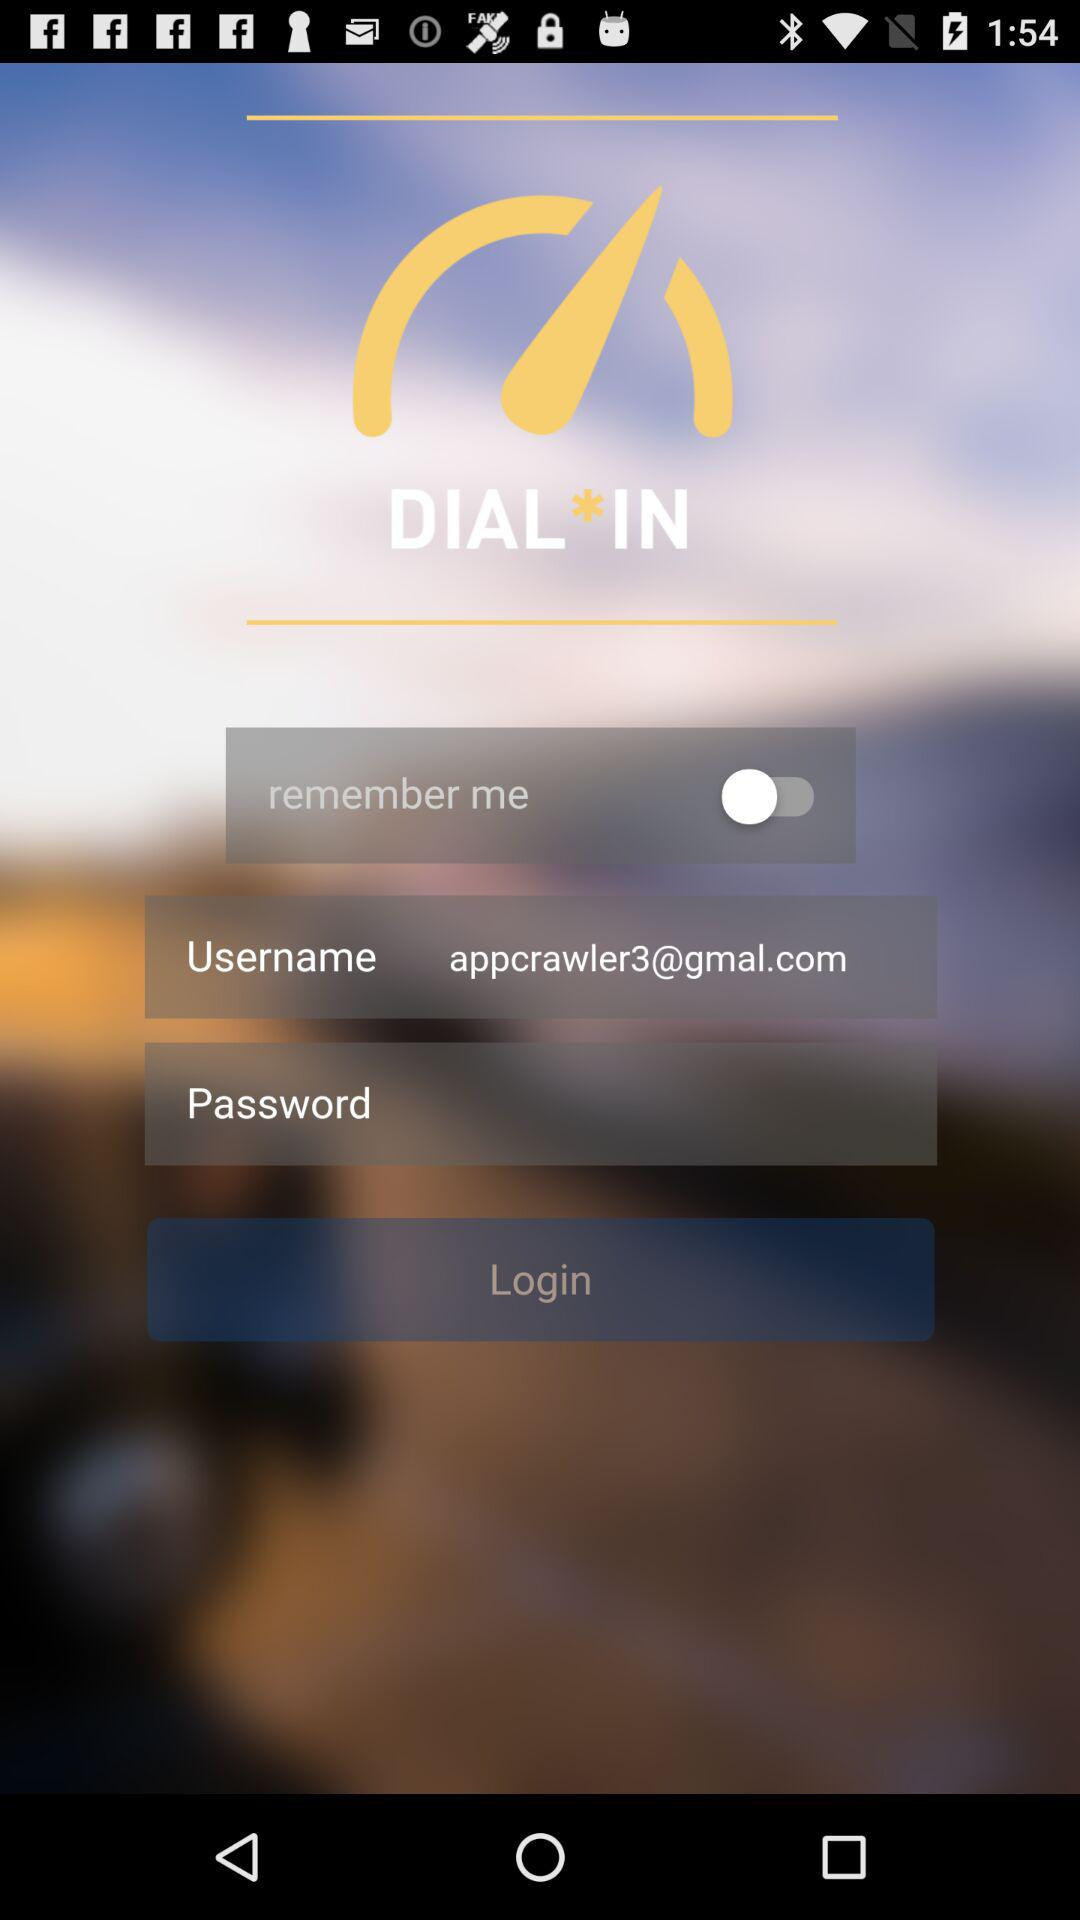What is the status of "remember me"? The status is "off". 